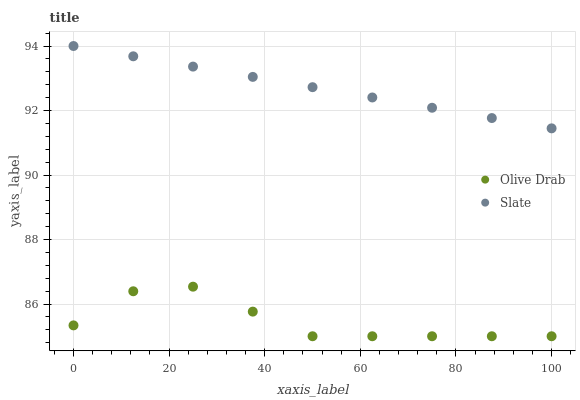Does Olive Drab have the minimum area under the curve?
Answer yes or no. Yes. Does Slate have the maximum area under the curve?
Answer yes or no. Yes. Does Olive Drab have the maximum area under the curve?
Answer yes or no. No. Is Slate the smoothest?
Answer yes or no. Yes. Is Olive Drab the roughest?
Answer yes or no. Yes. Is Olive Drab the smoothest?
Answer yes or no. No. Does Olive Drab have the lowest value?
Answer yes or no. Yes. Does Slate have the highest value?
Answer yes or no. Yes. Does Olive Drab have the highest value?
Answer yes or no. No. Is Olive Drab less than Slate?
Answer yes or no. Yes. Is Slate greater than Olive Drab?
Answer yes or no. Yes. Does Olive Drab intersect Slate?
Answer yes or no. No. 